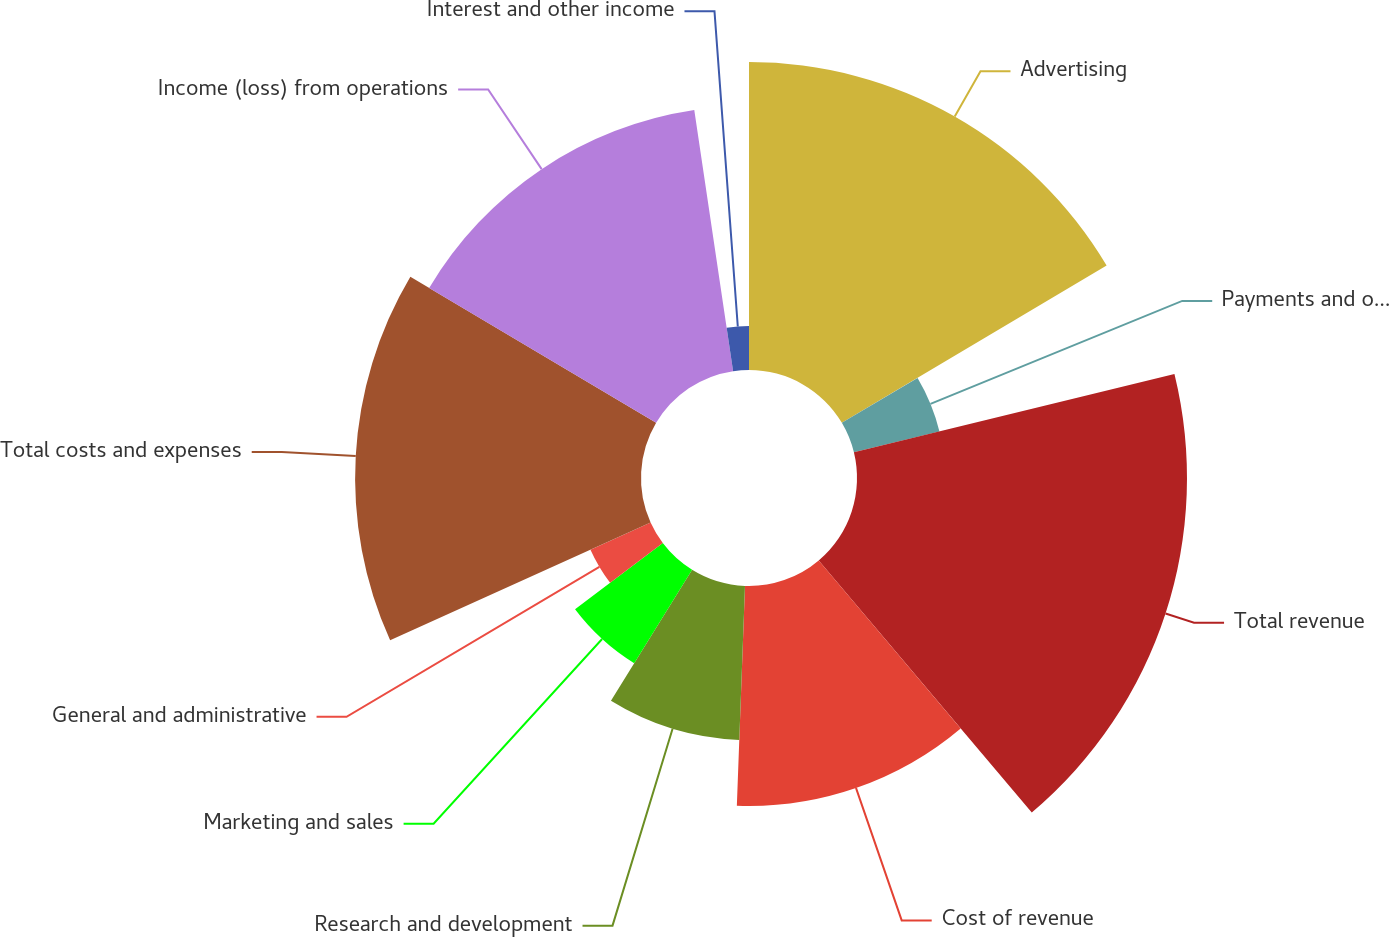Convert chart. <chart><loc_0><loc_0><loc_500><loc_500><pie_chart><fcel>Advertising<fcel>Payments and other fees (1)<fcel>Total revenue<fcel>Cost of revenue<fcel>Research and development<fcel>Marketing and sales<fcel>General and administrative<fcel>Total costs and expenses<fcel>Income (loss) from operations<fcel>Interest and other income<nl><fcel>16.47%<fcel>4.71%<fcel>17.65%<fcel>11.76%<fcel>8.24%<fcel>5.88%<fcel>3.53%<fcel>15.29%<fcel>14.12%<fcel>2.35%<nl></chart> 